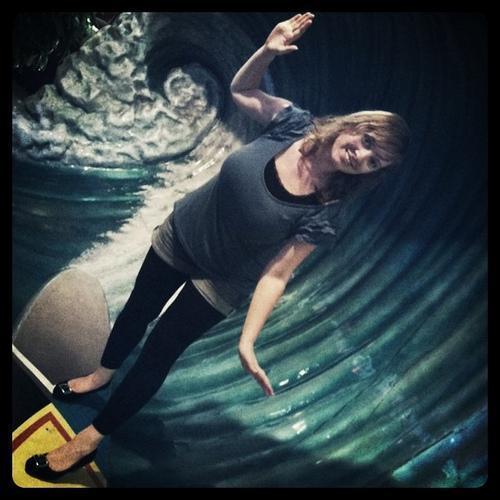How many women are there?
Give a very brief answer. 1. How many pink shoes does the person have?
Give a very brief answer. 0. 